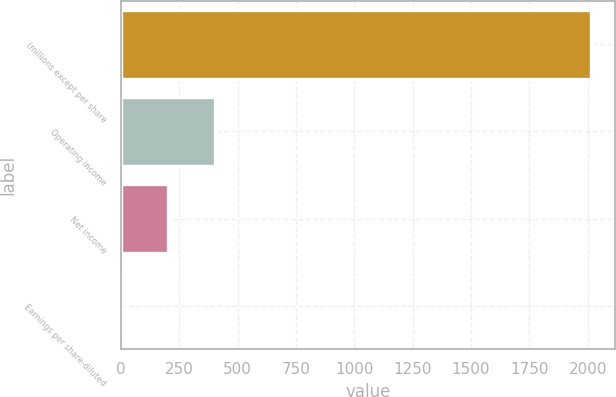Convert chart to OTSL. <chart><loc_0><loc_0><loc_500><loc_500><bar_chart><fcel>(millions except per share<fcel>Operating income<fcel>Net income<fcel>Earnings per share-diluted<nl><fcel>2015<fcel>403.29<fcel>201.83<fcel>0.37<nl></chart> 